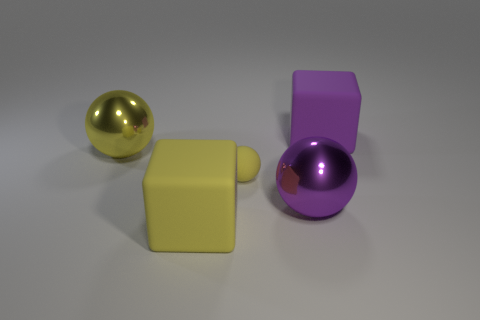Subtract all yellow matte spheres. How many spheres are left? 2 Add 3 tiny yellow rubber objects. How many objects exist? 8 Subtract all yellow spheres. How many spheres are left? 1 Subtract 1 blocks. How many blocks are left? 1 Subtract all brown balls. Subtract all blue cylinders. How many balls are left? 3 Subtract all yellow cylinders. How many purple balls are left? 1 Subtract all matte things. Subtract all yellow metallic objects. How many objects are left? 1 Add 4 shiny things. How many shiny things are left? 6 Add 5 small yellow things. How many small yellow things exist? 6 Subtract 0 green spheres. How many objects are left? 5 